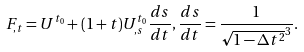Convert formula to latex. <formula><loc_0><loc_0><loc_500><loc_500>F _ { , t } = U ^ { t _ { 0 } } + ( 1 + t ) U ^ { t _ { 0 } } _ { , s } \frac { d s } { d t } , \frac { d s } { d t } = \frac { 1 } { \sqrt { 1 - \Delta t ^ { 2 } } ^ { 3 } } .</formula> 